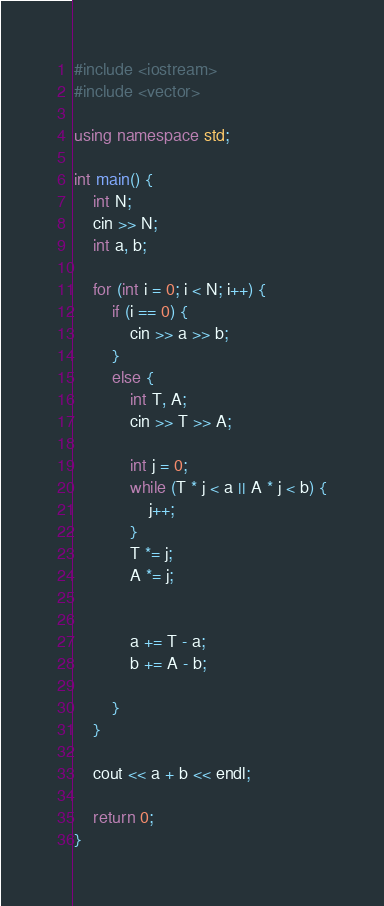<code> <loc_0><loc_0><loc_500><loc_500><_C++_>#include <iostream>
#include <vector>

using namespace std;

int main() {
	int N;
	cin >> N;
	int a, b;

	for (int i = 0; i < N; i++) {
		if (i == 0) {
			cin >> a >> b;
		}
		else {
			int T, A;
			cin >> T >> A;

			int j = 0;
			while (T * j < a || A * j < b) {
				j++;
			}
			T *= j;
			A *= j;


			a += T - a;
			b += A - b;

		}
	}

	cout << a + b << endl;

	return 0;
}</code> 